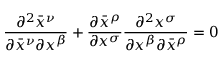<formula> <loc_0><loc_0><loc_500><loc_500>{ \frac { \partial ^ { 2 } { \bar { x } } ^ { \nu } } { \partial { \bar { x } } ^ { \nu } \partial x ^ { \beta } } } + { \frac { \partial { \bar { x } } ^ { \rho } } { \partial x ^ { \sigma } } } { \frac { \partial ^ { 2 } x ^ { \sigma } } { \partial x ^ { \beta } \partial { \bar { x } } ^ { \rho } } } = 0</formula> 